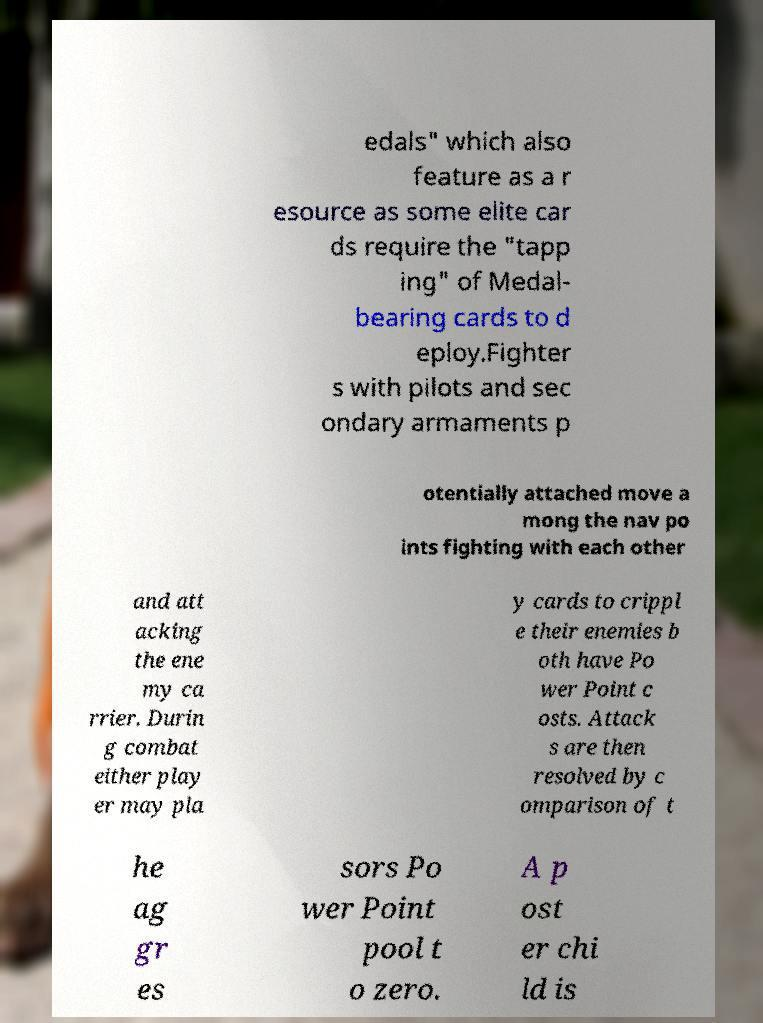I need the written content from this picture converted into text. Can you do that? edals" which also feature as a r esource as some elite car ds require the "tapp ing" of Medal- bearing cards to d eploy.Fighter s with pilots and sec ondary armaments p otentially attached move a mong the nav po ints fighting with each other and att acking the ene my ca rrier. Durin g combat either play er may pla y cards to crippl e their enemies b oth have Po wer Point c osts. Attack s are then resolved by c omparison of t he ag gr es sors Po wer Point pool t o zero. A p ost er chi ld is 